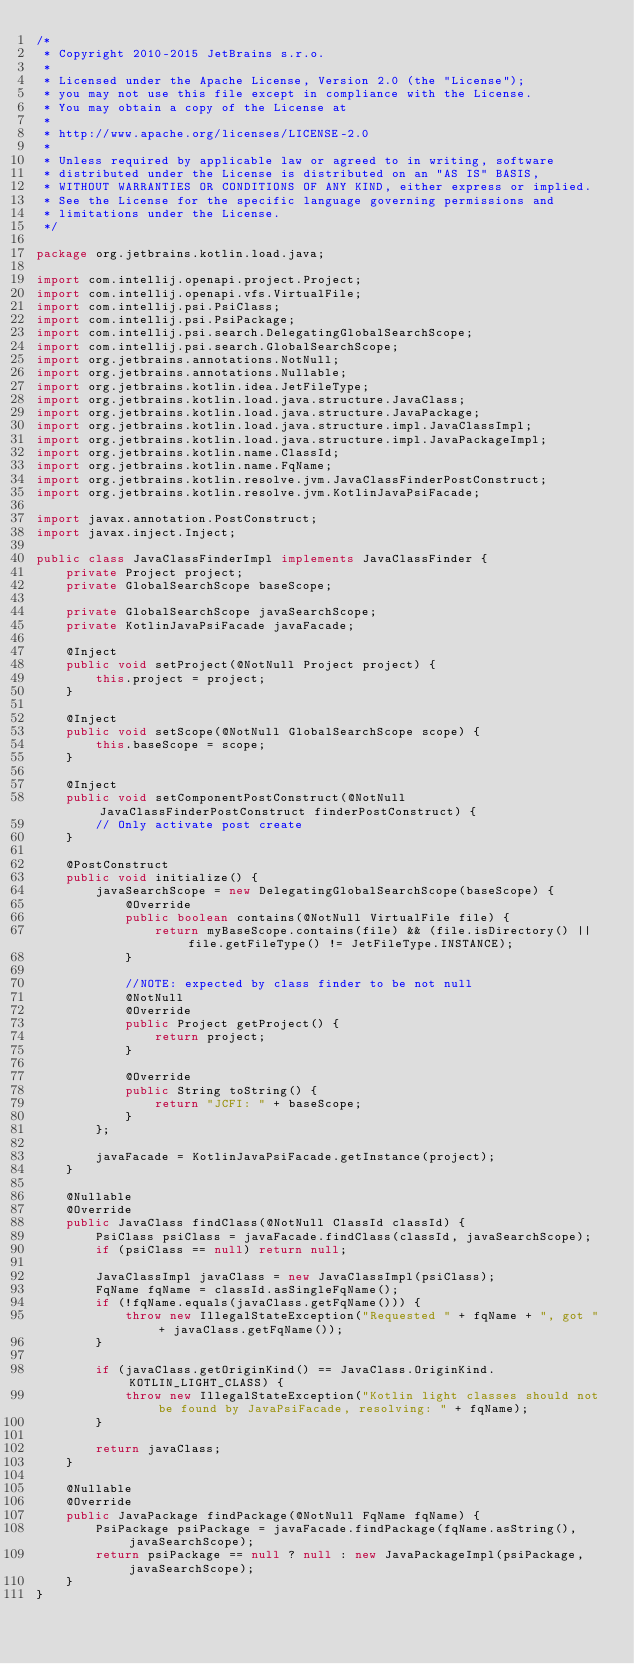Convert code to text. <code><loc_0><loc_0><loc_500><loc_500><_Java_>/*
 * Copyright 2010-2015 JetBrains s.r.o.
 *
 * Licensed under the Apache License, Version 2.0 (the "License");
 * you may not use this file except in compliance with the License.
 * You may obtain a copy of the License at
 *
 * http://www.apache.org/licenses/LICENSE-2.0
 *
 * Unless required by applicable law or agreed to in writing, software
 * distributed under the License is distributed on an "AS IS" BASIS,
 * WITHOUT WARRANTIES OR CONDITIONS OF ANY KIND, either express or implied.
 * See the License for the specific language governing permissions and
 * limitations under the License.
 */

package org.jetbrains.kotlin.load.java;

import com.intellij.openapi.project.Project;
import com.intellij.openapi.vfs.VirtualFile;
import com.intellij.psi.PsiClass;
import com.intellij.psi.PsiPackage;
import com.intellij.psi.search.DelegatingGlobalSearchScope;
import com.intellij.psi.search.GlobalSearchScope;
import org.jetbrains.annotations.NotNull;
import org.jetbrains.annotations.Nullable;
import org.jetbrains.kotlin.idea.JetFileType;
import org.jetbrains.kotlin.load.java.structure.JavaClass;
import org.jetbrains.kotlin.load.java.structure.JavaPackage;
import org.jetbrains.kotlin.load.java.structure.impl.JavaClassImpl;
import org.jetbrains.kotlin.load.java.structure.impl.JavaPackageImpl;
import org.jetbrains.kotlin.name.ClassId;
import org.jetbrains.kotlin.name.FqName;
import org.jetbrains.kotlin.resolve.jvm.JavaClassFinderPostConstruct;
import org.jetbrains.kotlin.resolve.jvm.KotlinJavaPsiFacade;

import javax.annotation.PostConstruct;
import javax.inject.Inject;

public class JavaClassFinderImpl implements JavaClassFinder {
    private Project project;
    private GlobalSearchScope baseScope;

    private GlobalSearchScope javaSearchScope;
    private KotlinJavaPsiFacade javaFacade;

    @Inject
    public void setProject(@NotNull Project project) {
        this.project = project;
    }

    @Inject
    public void setScope(@NotNull GlobalSearchScope scope) {
        this.baseScope = scope;
    }

    @Inject
    public void setComponentPostConstruct(@NotNull JavaClassFinderPostConstruct finderPostConstruct) {
        // Only activate post create
    }

    @PostConstruct
    public void initialize() {
        javaSearchScope = new DelegatingGlobalSearchScope(baseScope) {
            @Override
            public boolean contains(@NotNull VirtualFile file) {
                return myBaseScope.contains(file) && (file.isDirectory() || file.getFileType() != JetFileType.INSTANCE);
            }

            //NOTE: expected by class finder to be not null
            @NotNull
            @Override
            public Project getProject() {
                return project;
            }

            @Override
            public String toString() {
                return "JCFI: " + baseScope;
            }
        };

        javaFacade = KotlinJavaPsiFacade.getInstance(project);
    }

    @Nullable
    @Override
    public JavaClass findClass(@NotNull ClassId classId) {
        PsiClass psiClass = javaFacade.findClass(classId, javaSearchScope);
        if (psiClass == null) return null;

        JavaClassImpl javaClass = new JavaClassImpl(psiClass);
        FqName fqName = classId.asSingleFqName();
        if (!fqName.equals(javaClass.getFqName())) {
            throw new IllegalStateException("Requested " + fqName + ", got " + javaClass.getFqName());
        }

        if (javaClass.getOriginKind() == JavaClass.OriginKind.KOTLIN_LIGHT_CLASS) {
            throw new IllegalStateException("Kotlin light classes should not be found by JavaPsiFacade, resolving: " + fqName);
        }

        return javaClass;
    }

    @Nullable
    @Override
    public JavaPackage findPackage(@NotNull FqName fqName) {
        PsiPackage psiPackage = javaFacade.findPackage(fqName.asString(), javaSearchScope);
        return psiPackage == null ? null : new JavaPackageImpl(psiPackage, javaSearchScope);
    }
}
</code> 